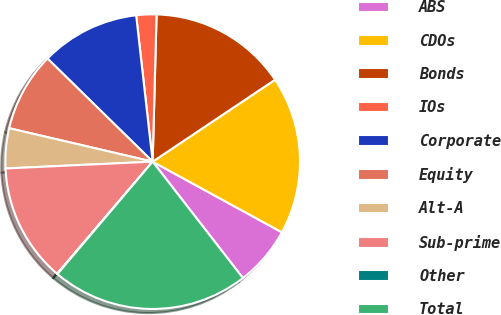Convert chart to OTSL. <chart><loc_0><loc_0><loc_500><loc_500><pie_chart><fcel>ABS<fcel>CDOs<fcel>Bonds<fcel>IOs<fcel>Corporate<fcel>Equity<fcel>Alt-A<fcel>Sub-prime<fcel>Other<fcel>Total<nl><fcel>6.54%<fcel>17.35%<fcel>15.19%<fcel>2.21%<fcel>10.87%<fcel>8.7%<fcel>4.38%<fcel>13.03%<fcel>0.05%<fcel>21.68%<nl></chart> 